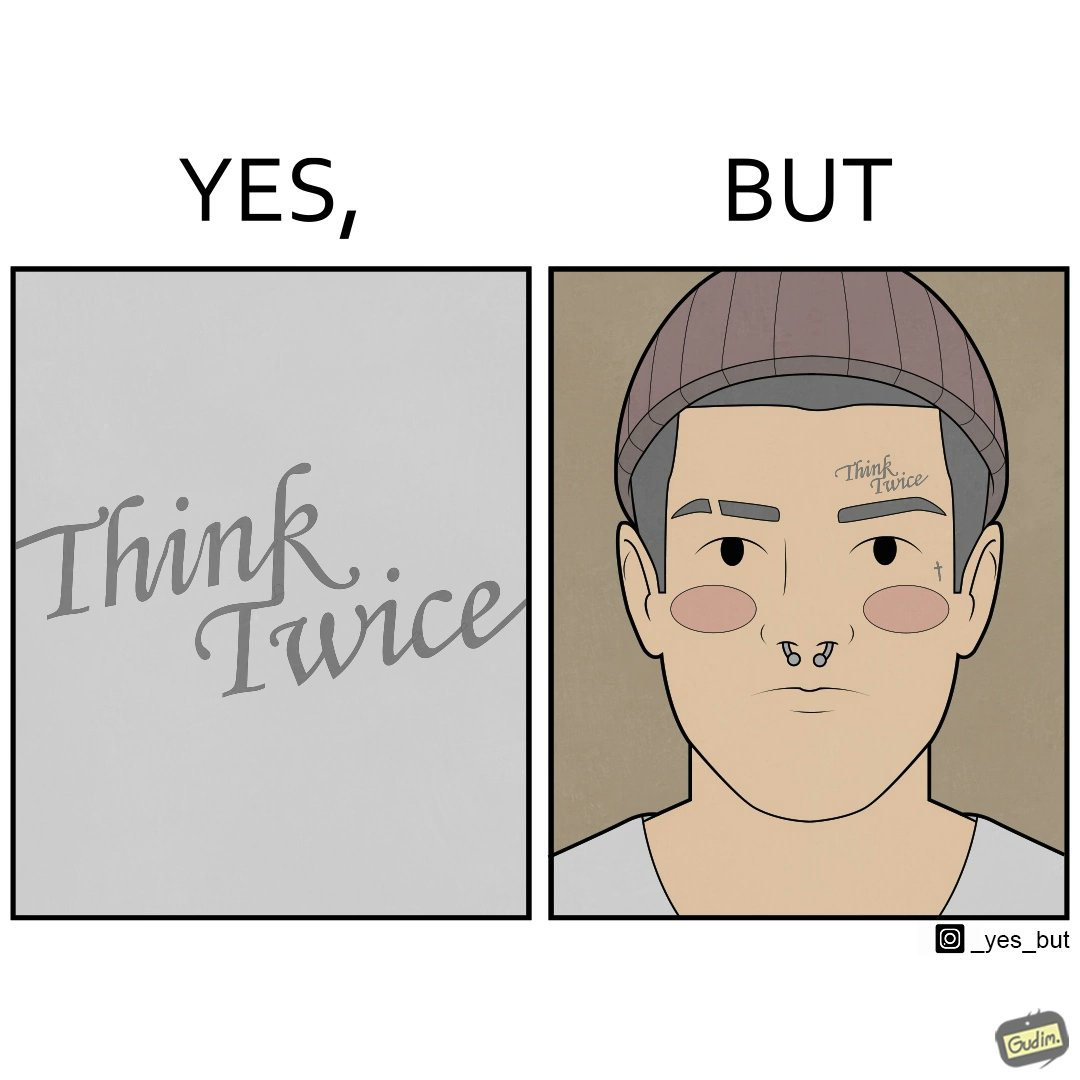What do you see in each half of this image? In the left part of the image: The image shows a text in english saying "Think Twice". The font seems very fashionable. In the right part of the image: The image shows the face of a man with a tattoo on the left side of a forehead saying "Think Twice". The man is wearing a nose ring and has a cut on his left eyebrow. He also has a small tattoo of the cross a little below his left eye. 